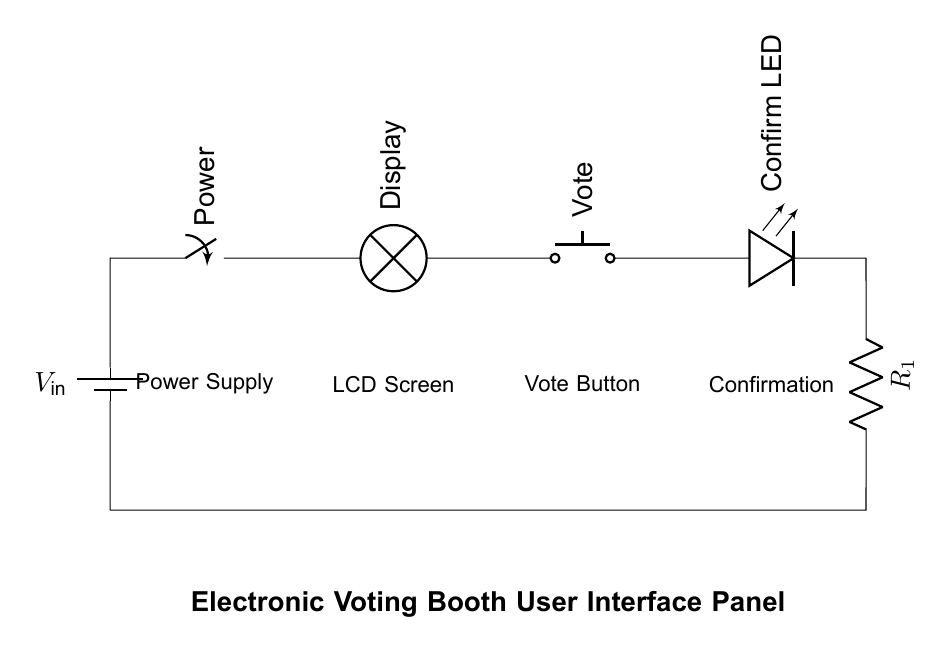What is the total number of components in the circuit? There are five components visible in the circuit diagram: a battery, switch, lamp, push button, and LED.
Answer: Five What is the function of the lamp in this circuit? The lamp represents the display, which is likely used to show information to the user during the voting process.
Answer: Display What type of components are used in this series circuit? The circuit consists of resistive and active components, specifically a battery (active), a switch (passive), a lamp (active), a push button (active), and an LED (active).
Answer: Active and passive What does pressing the push button do? Pressing the push button completes the circuit, allowing current to flow and activating the confirmation LED to indicate that the vote has been registered.
Answer: Activates confirmation What is the role of the resistor in this circuit? The resistor is used to limit the current flowing through the confirmation LED, preventing it from drawing too much current and potentially burning out.
Answer: Current limiting How is the power supplied to the circuit? The circuit is powered by a battery, which provides the necessary voltage to drive all components.
Answer: Battery What happens if the switch is opened? If the switch is opened, the circuit will be broken, and no current will flow, resulting in all components being inactive and there being no display or confirmation.
Answer: Circuit breaks 